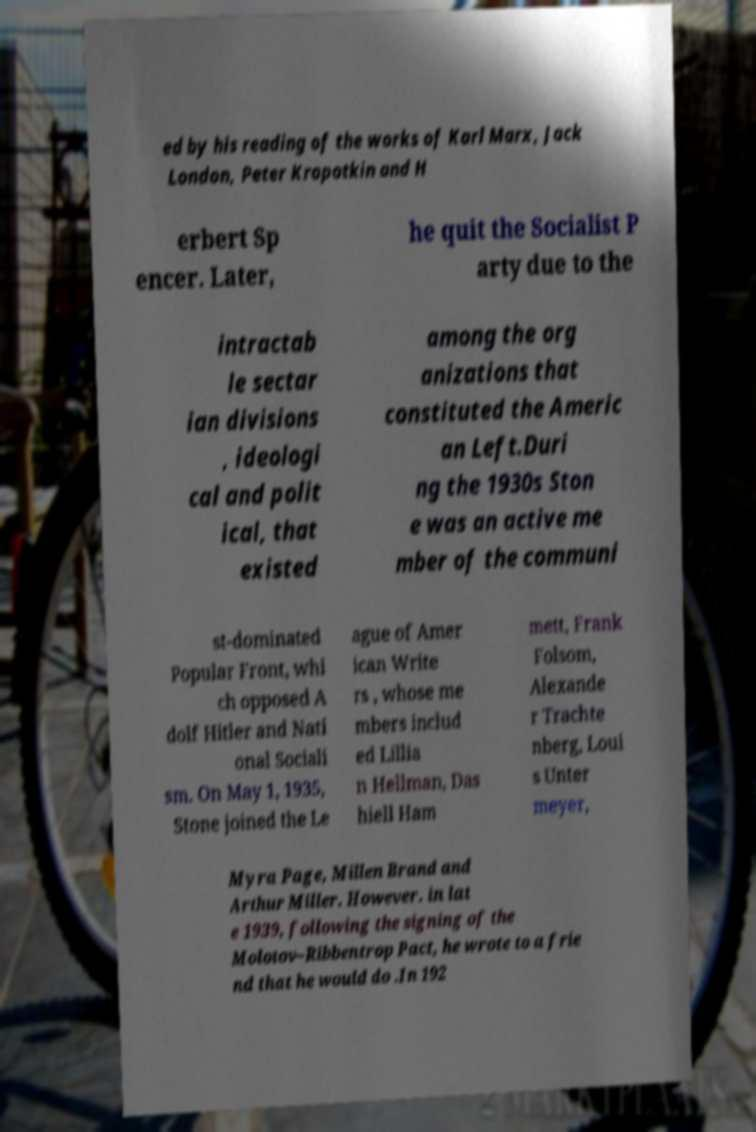What messages or text are displayed in this image? I need them in a readable, typed format. ed by his reading of the works of Karl Marx, Jack London, Peter Kropotkin and H erbert Sp encer. Later, he quit the Socialist P arty due to the intractab le sectar ian divisions , ideologi cal and polit ical, that existed among the org anizations that constituted the Americ an Left.Duri ng the 1930s Ston e was an active me mber of the communi st-dominated Popular Front, whi ch opposed A dolf Hitler and Nati onal Sociali sm. On May 1, 1935, Stone joined the Le ague of Amer ican Write rs , whose me mbers includ ed Lillia n Hellman, Das hiell Ham mett, Frank Folsom, Alexande r Trachte nberg, Loui s Unter meyer, Myra Page, Millen Brand and Arthur Miller. However. in lat e 1939, following the signing of the Molotov–Ribbentrop Pact, he wrote to a frie nd that he would do .In 192 